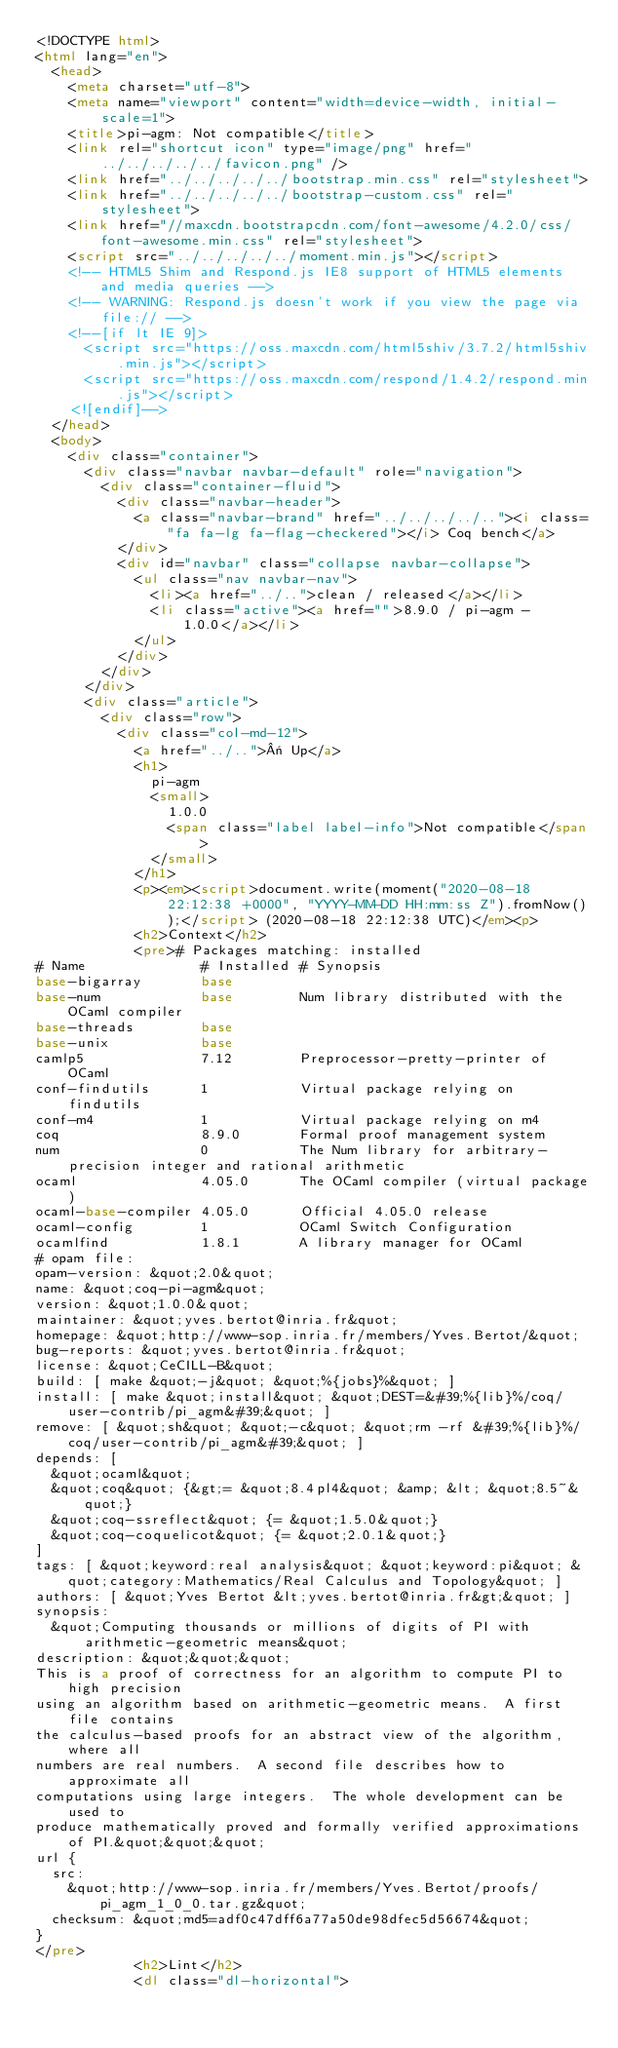Convert code to text. <code><loc_0><loc_0><loc_500><loc_500><_HTML_><!DOCTYPE html>
<html lang="en">
  <head>
    <meta charset="utf-8">
    <meta name="viewport" content="width=device-width, initial-scale=1">
    <title>pi-agm: Not compatible</title>
    <link rel="shortcut icon" type="image/png" href="../../../../../favicon.png" />
    <link href="../../../../../bootstrap.min.css" rel="stylesheet">
    <link href="../../../../../bootstrap-custom.css" rel="stylesheet">
    <link href="//maxcdn.bootstrapcdn.com/font-awesome/4.2.0/css/font-awesome.min.css" rel="stylesheet">
    <script src="../../../../../moment.min.js"></script>
    <!-- HTML5 Shim and Respond.js IE8 support of HTML5 elements and media queries -->
    <!-- WARNING: Respond.js doesn't work if you view the page via file:// -->
    <!--[if lt IE 9]>
      <script src="https://oss.maxcdn.com/html5shiv/3.7.2/html5shiv.min.js"></script>
      <script src="https://oss.maxcdn.com/respond/1.4.2/respond.min.js"></script>
    <![endif]-->
  </head>
  <body>
    <div class="container">
      <div class="navbar navbar-default" role="navigation">
        <div class="container-fluid">
          <div class="navbar-header">
            <a class="navbar-brand" href="../../../../.."><i class="fa fa-lg fa-flag-checkered"></i> Coq bench</a>
          </div>
          <div id="navbar" class="collapse navbar-collapse">
            <ul class="nav navbar-nav">
              <li><a href="../..">clean / released</a></li>
              <li class="active"><a href="">8.9.0 / pi-agm - 1.0.0</a></li>
            </ul>
          </div>
        </div>
      </div>
      <div class="article">
        <div class="row">
          <div class="col-md-12">
            <a href="../..">« Up</a>
            <h1>
              pi-agm
              <small>
                1.0.0
                <span class="label label-info">Not compatible</span>
              </small>
            </h1>
            <p><em><script>document.write(moment("2020-08-18 22:12:38 +0000", "YYYY-MM-DD HH:mm:ss Z").fromNow());</script> (2020-08-18 22:12:38 UTC)</em><p>
            <h2>Context</h2>
            <pre># Packages matching: installed
# Name              # Installed # Synopsis
base-bigarray       base
base-num            base        Num library distributed with the OCaml compiler
base-threads        base
base-unix           base
camlp5              7.12        Preprocessor-pretty-printer of OCaml
conf-findutils      1           Virtual package relying on findutils
conf-m4             1           Virtual package relying on m4
coq                 8.9.0       Formal proof management system
num                 0           The Num library for arbitrary-precision integer and rational arithmetic
ocaml               4.05.0      The OCaml compiler (virtual package)
ocaml-base-compiler 4.05.0      Official 4.05.0 release
ocaml-config        1           OCaml Switch Configuration
ocamlfind           1.8.1       A library manager for OCaml
# opam file:
opam-version: &quot;2.0&quot;
name: &quot;coq-pi-agm&quot;
version: &quot;1.0.0&quot;
maintainer: &quot;yves.bertot@inria.fr&quot;
homepage: &quot;http://www-sop.inria.fr/members/Yves.Bertot/&quot;
bug-reports: &quot;yves.bertot@inria.fr&quot;
license: &quot;CeCILL-B&quot;
build: [ make &quot;-j&quot; &quot;%{jobs}%&quot; ]
install: [ make &quot;install&quot; &quot;DEST=&#39;%{lib}%/coq/user-contrib/pi_agm&#39;&quot; ]
remove: [ &quot;sh&quot; &quot;-c&quot; &quot;rm -rf &#39;%{lib}%/coq/user-contrib/pi_agm&#39;&quot; ]
depends: [
  &quot;ocaml&quot;
  &quot;coq&quot; {&gt;= &quot;8.4pl4&quot; &amp; &lt; &quot;8.5~&quot;}
  &quot;coq-ssreflect&quot; {= &quot;1.5.0&quot;}
  &quot;coq-coquelicot&quot; {= &quot;2.0.1&quot;}
]
tags: [ &quot;keyword:real analysis&quot; &quot;keyword:pi&quot; &quot;category:Mathematics/Real Calculus and Topology&quot; ]
authors: [ &quot;Yves Bertot &lt;yves.bertot@inria.fr&gt;&quot; ]
synopsis:
  &quot;Computing thousands or millions of digits of PI with arithmetic-geometric means&quot;
description: &quot;&quot;&quot;
This is a proof of correctness for an algorithm to compute PI to high precision
using an algorithm based on arithmetic-geometric means.  A first file contains
the calculus-based proofs for an abstract view of the algorithm, where all
numbers are real numbers.  A second file describes how to approximate all
computations using large integers.  The whole development can be used to
produce mathematically proved and formally verified approximations of PI.&quot;&quot;&quot;
url {
  src:
    &quot;http://www-sop.inria.fr/members/Yves.Bertot/proofs/pi_agm_1_0_0.tar.gz&quot;
  checksum: &quot;md5=adf0c47dff6a77a50de98dfec5d56674&quot;
}
</pre>
            <h2>Lint</h2>
            <dl class="dl-horizontal"></code> 